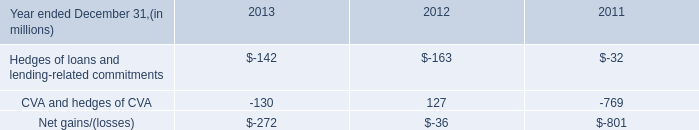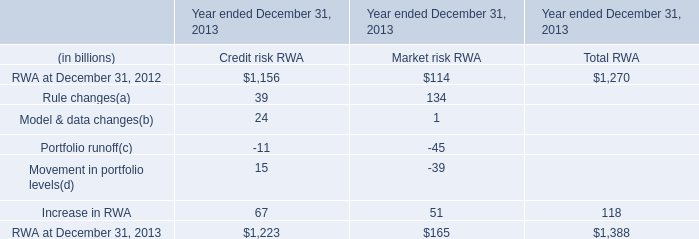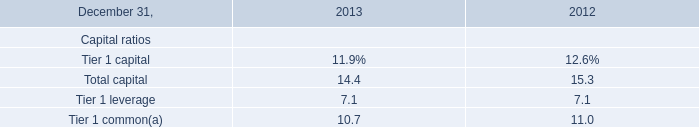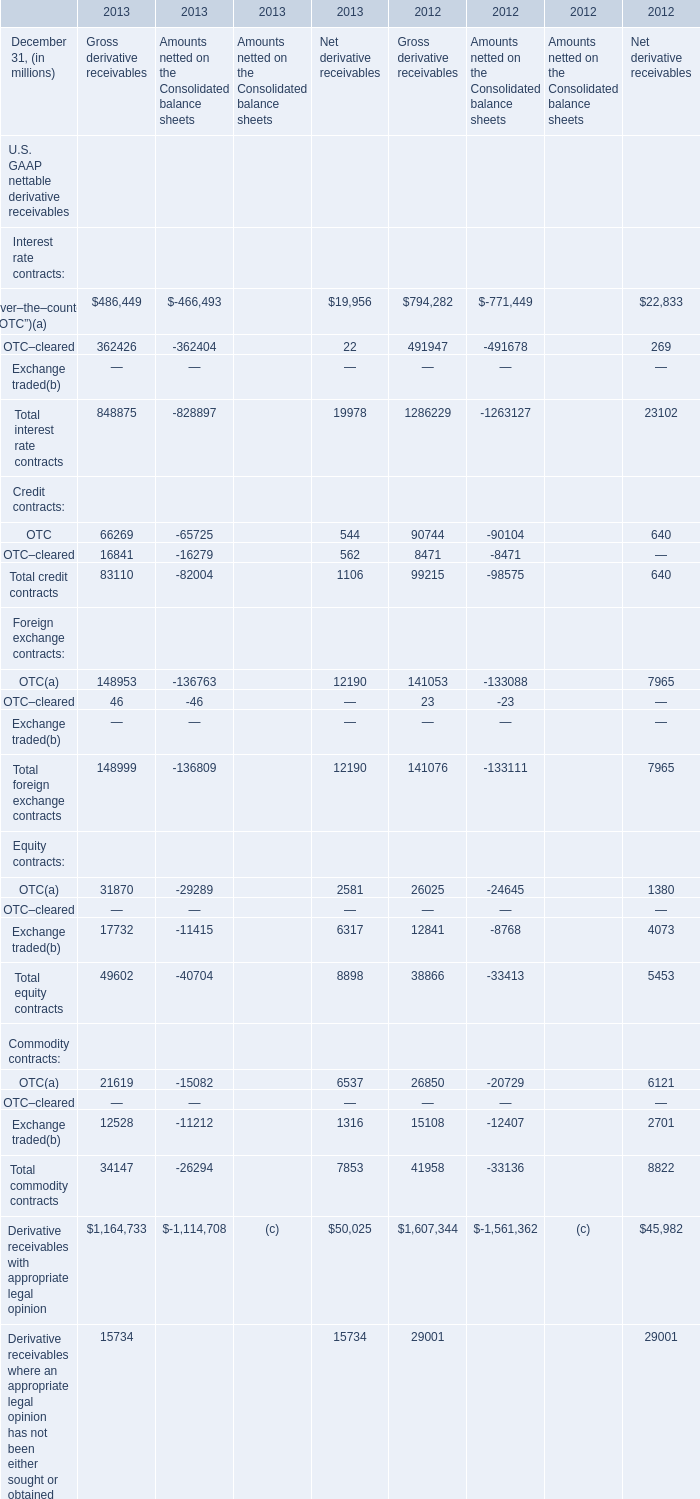What is the growing rate of total interest rate contracts of Net derivative receivables in the year with the most Total credit contracts of Net derivative receivables? (in %) 
Computations: ((19978 - 23102) / 23102)
Answer: -0.13523. 